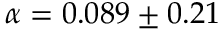<formula> <loc_0><loc_0><loc_500><loc_500>\alpha = 0 . 0 8 9 \pm 0 . 2 1</formula> 